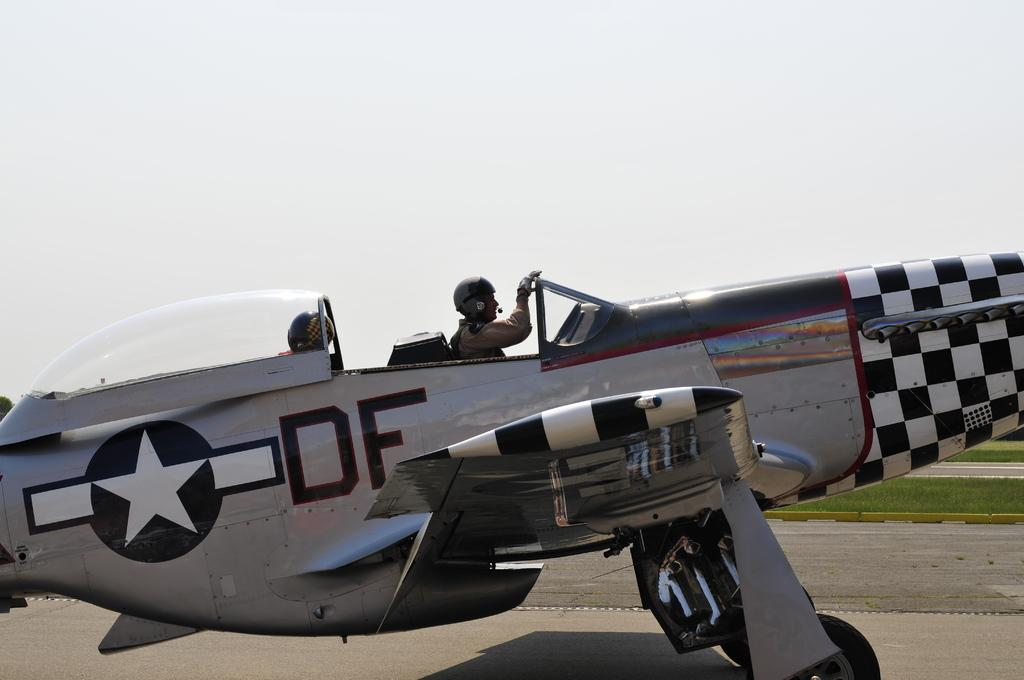<image>
Present a compact description of the photo's key features. An old propellor plane on a runway with DF written on the side. 